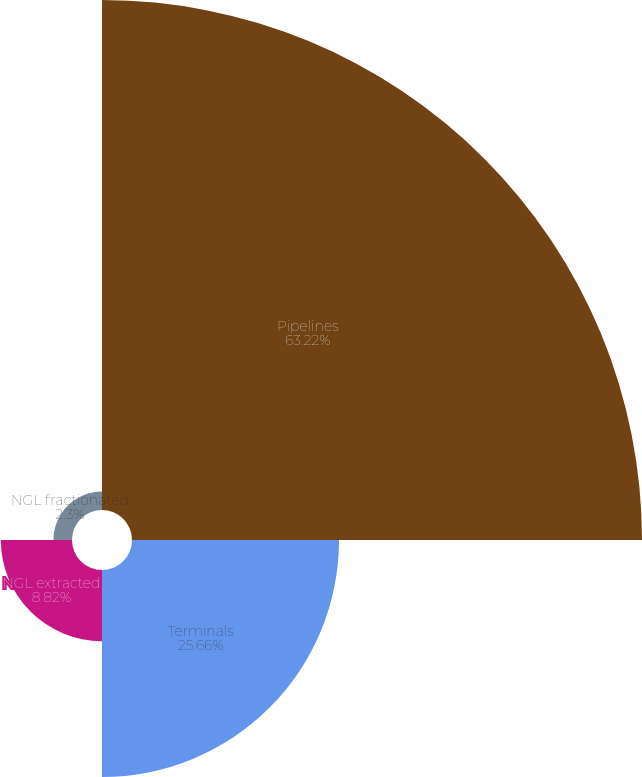<chart> <loc_0><loc_0><loc_500><loc_500><pie_chart><fcel>Pipelines<fcel>Terminals<fcel>NGL extracted<fcel>NGL fractionated<nl><fcel>63.21%<fcel>25.66%<fcel>8.82%<fcel>2.3%<nl></chart> 